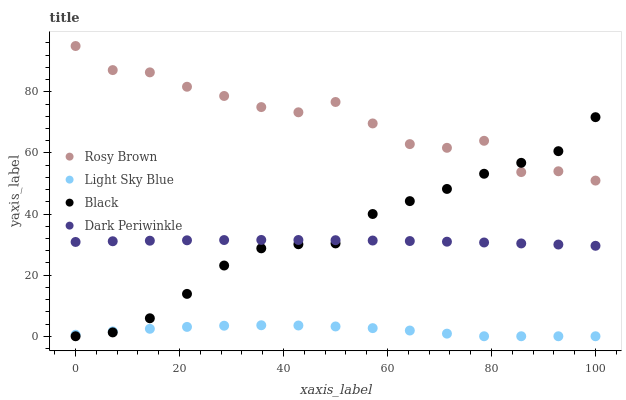Does Light Sky Blue have the minimum area under the curve?
Answer yes or no. Yes. Does Rosy Brown have the maximum area under the curve?
Answer yes or no. Yes. Does Black have the minimum area under the curve?
Answer yes or no. No. Does Black have the maximum area under the curve?
Answer yes or no. No. Is Dark Periwinkle the smoothest?
Answer yes or no. Yes. Is Rosy Brown the roughest?
Answer yes or no. Yes. Is Black the smoothest?
Answer yes or no. No. Is Black the roughest?
Answer yes or no. No. Does Black have the lowest value?
Answer yes or no. Yes. Does Dark Periwinkle have the lowest value?
Answer yes or no. No. Does Rosy Brown have the highest value?
Answer yes or no. Yes. Does Black have the highest value?
Answer yes or no. No. Is Dark Periwinkle less than Rosy Brown?
Answer yes or no. Yes. Is Rosy Brown greater than Dark Periwinkle?
Answer yes or no. Yes. Does Rosy Brown intersect Black?
Answer yes or no. Yes. Is Rosy Brown less than Black?
Answer yes or no. No. Is Rosy Brown greater than Black?
Answer yes or no. No. Does Dark Periwinkle intersect Rosy Brown?
Answer yes or no. No. 